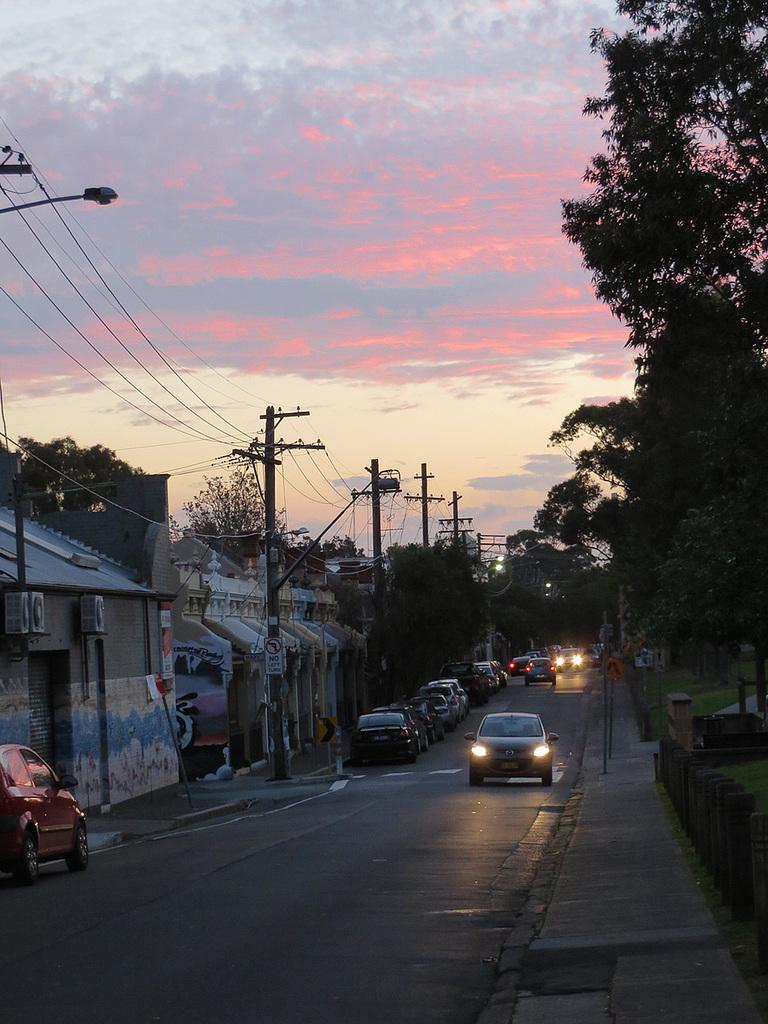What can be seen on the road in the image? There are cars on the road in the image. What else is present in the image besides the cars? Utility poles with wires, buildings, trees, poles on the footpath, and grass are visible in the image. What is the condition of the sky in the image? The sky is visible in the image, and it appears cloudy. What type of vacation is being planned by the boundary in the image? There is no mention of a vacation or boundary in the image; it primarily features cars on the road, utility poles, buildings, trees, poles on the footpath, grass, and a cloudy sky. 